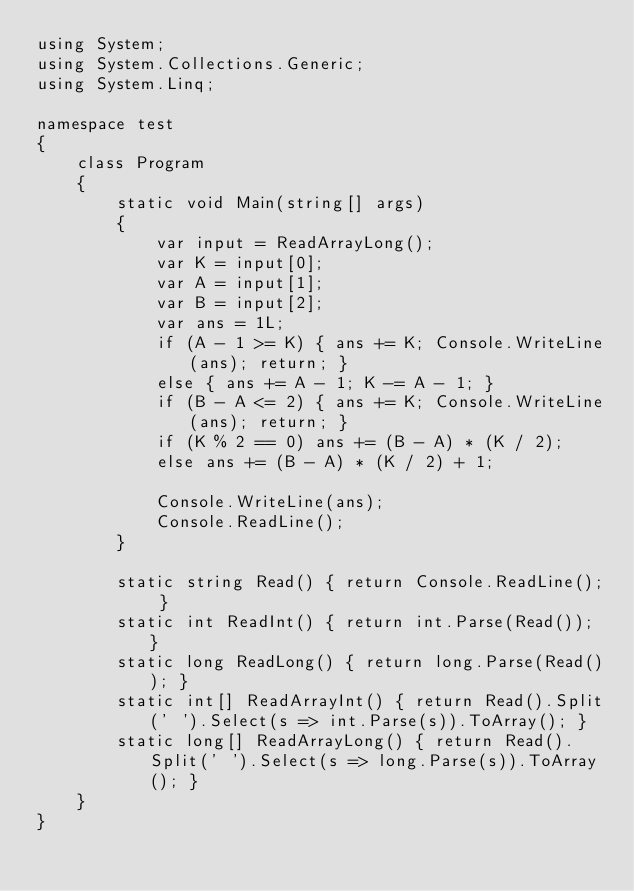Convert code to text. <code><loc_0><loc_0><loc_500><loc_500><_C#_>using System;
using System.Collections.Generic;
using System.Linq;

namespace test
{
    class Program
    {
        static void Main(string[] args)
        {
            var input = ReadArrayLong();
            var K = input[0];
            var A = input[1];
            var B = input[2];
            var ans = 1L;
            if (A - 1 >= K) { ans += K; Console.WriteLine(ans); return; }
            else { ans += A - 1; K -= A - 1; }
            if (B - A <= 2) { ans += K; Console.WriteLine(ans); return; }
            if (K % 2 == 0) ans += (B - A) * (K / 2);
            else ans += (B - A) * (K / 2) + 1;

            Console.WriteLine(ans);
            Console.ReadLine();
        }

        static string Read() { return Console.ReadLine(); }
        static int ReadInt() { return int.Parse(Read()); }
        static long ReadLong() { return long.Parse(Read()); }
        static int[] ReadArrayInt() { return Read().Split(' ').Select(s => int.Parse(s)).ToArray(); }
        static long[] ReadArrayLong() { return Read().Split(' ').Select(s => long.Parse(s)).ToArray(); }
    }
}</code> 